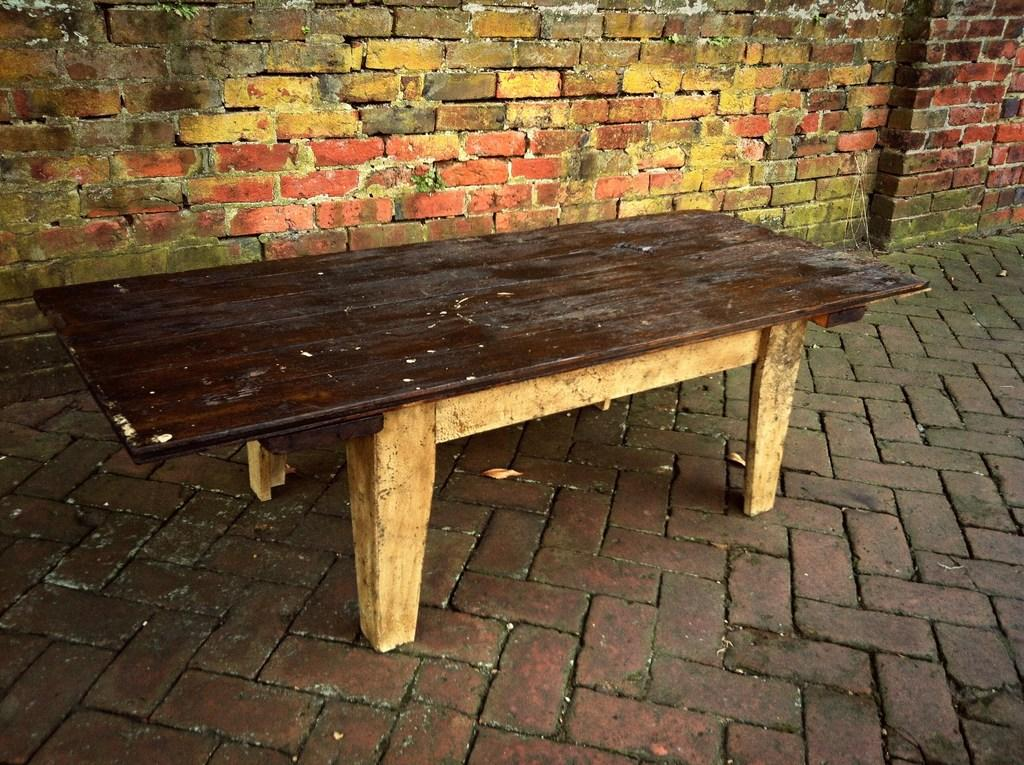What type of furniture is in the image? There is a wooden bench in the image. Where is the wooden bench located? The wooden bench is on the floor. What can be seen in the background of the image? There is a brick wall in the background of the image. What type of locket is hanging from the wooden bench in the image? There is no locket present in the image; it only features a wooden bench on the floor and a brick wall in the background. 